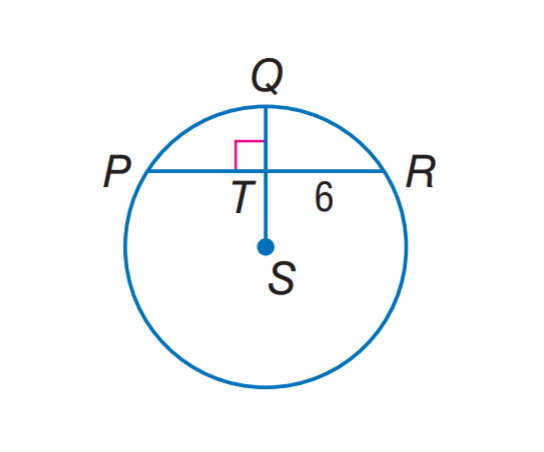Answer the mathemtical geometry problem and directly provide the correct option letter.
Question: In \odot S, find P R.
Choices: A: 6 B: 12 C: 14 D: 18 B 